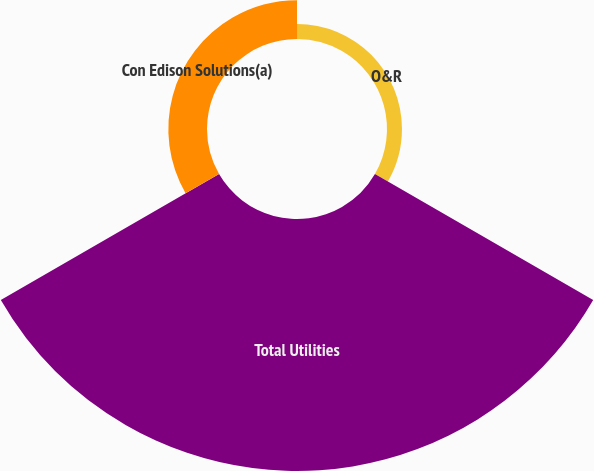Convert chart to OTSL. <chart><loc_0><loc_0><loc_500><loc_500><pie_chart><fcel>O&R<fcel>Total Utilities<fcel>Con Edison Solutions(a)<nl><fcel>4.9%<fcel>82.45%<fcel>12.65%<nl></chart> 